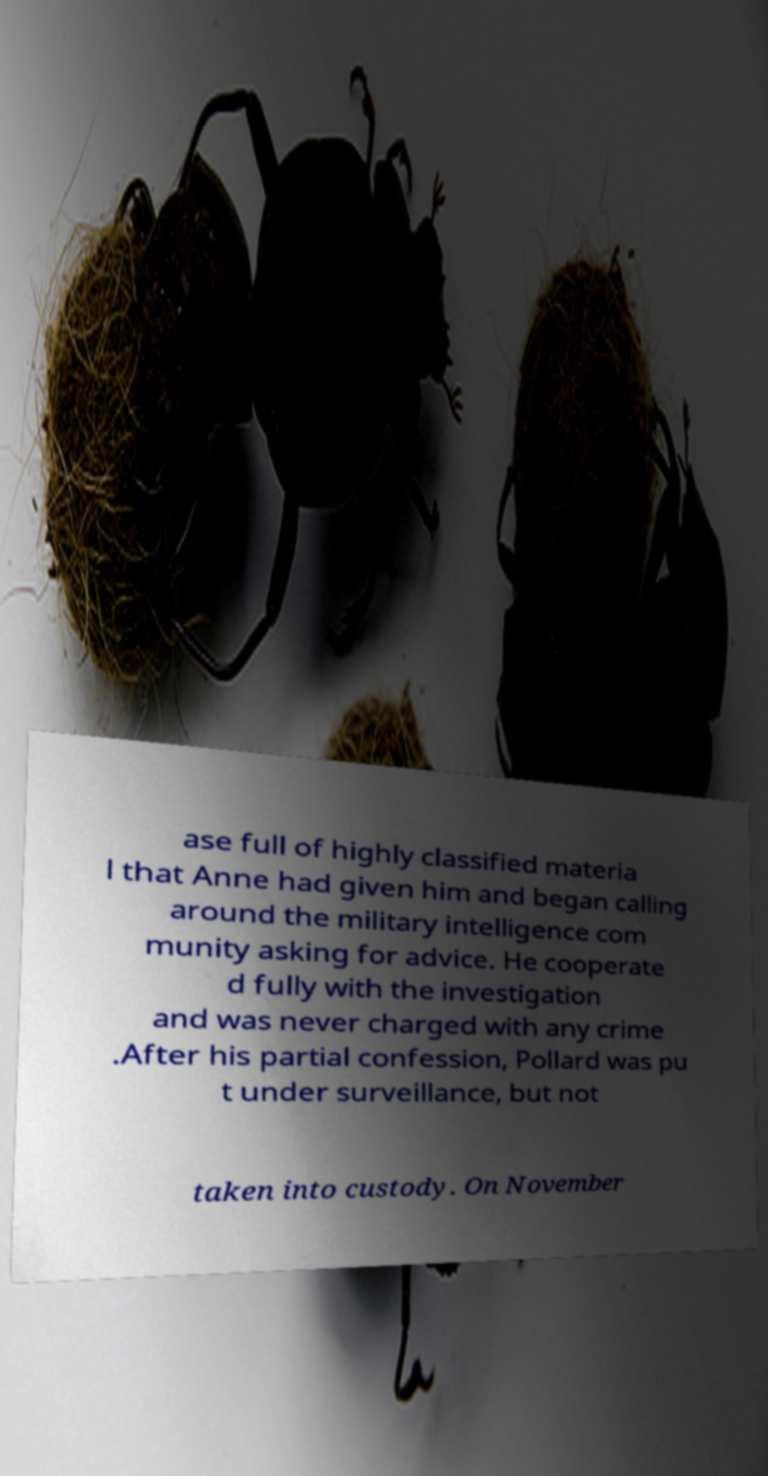There's text embedded in this image that I need extracted. Can you transcribe it verbatim? ase full of highly classified materia l that Anne had given him and began calling around the military intelligence com munity asking for advice. He cooperate d fully with the investigation and was never charged with any crime .After his partial confession, Pollard was pu t under surveillance, but not taken into custody. On November 